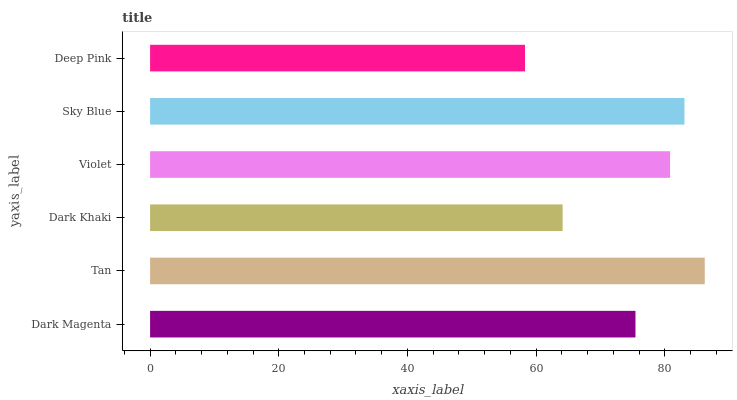Is Deep Pink the minimum?
Answer yes or no. Yes. Is Tan the maximum?
Answer yes or no. Yes. Is Dark Khaki the minimum?
Answer yes or no. No. Is Dark Khaki the maximum?
Answer yes or no. No. Is Tan greater than Dark Khaki?
Answer yes or no. Yes. Is Dark Khaki less than Tan?
Answer yes or no. Yes. Is Dark Khaki greater than Tan?
Answer yes or no. No. Is Tan less than Dark Khaki?
Answer yes or no. No. Is Violet the high median?
Answer yes or no. Yes. Is Dark Magenta the low median?
Answer yes or no. Yes. Is Dark Magenta the high median?
Answer yes or no. No. Is Sky Blue the low median?
Answer yes or no. No. 